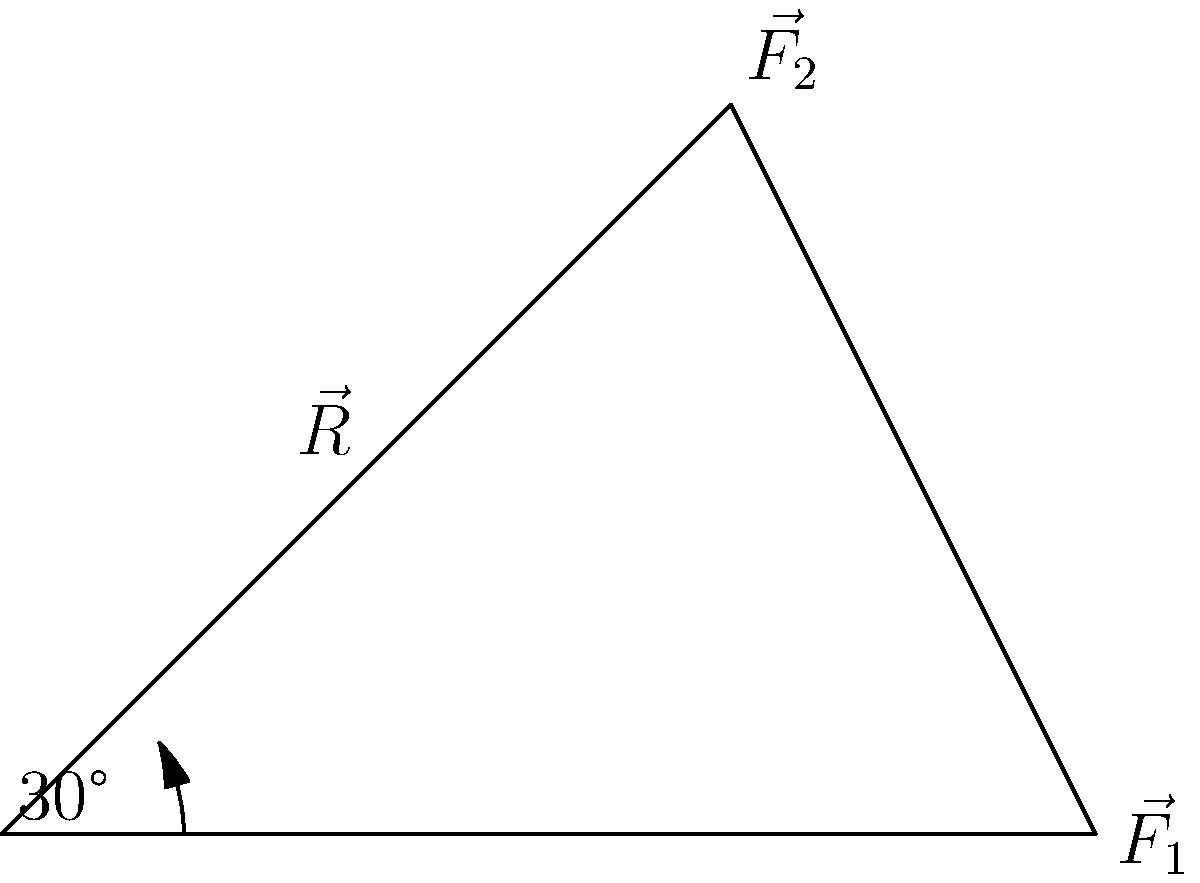A violinist is analyzing the forces acting on their bow during a performance. Two forces are applied to the bow: $\vec{F_1}$ with a magnitude of 3 N along the x-axis, and $\vec{F_2}$ with a magnitude of 2.83 N at an angle of 30° above the x-axis. Calculate the magnitude of the resultant force $\vec{R}$ acting on the bow. To find the magnitude of the resultant force, we'll use the following steps:

1) First, let's break down $\vec{F_2}$ into its x and y components:
   $F_{2x} = 2.83 \cos(30°) = 2.83 \cdot \frac{\sqrt{3}}{2} = 2.45$ N
   $F_{2y} = 2.83 \sin(30°) = 2.83 \cdot \frac{1}{2} = 1.415$ N

2) Now, we can sum the forces in the x and y directions:
   $R_x = F_1 + F_{2x} = 3 + 2.45 = 5.45$ N
   $R_y = F_{2y} = 1.415$ N

3) The magnitude of the resultant force can be calculated using the Pythagorean theorem:
   $|\vec{R}| = \sqrt{R_x^2 + R_y^2} = \sqrt{5.45^2 + 1.415^2}$

4) Simplifying:
   $|\vec{R}| = \sqrt{29.7025 + 2.002225} = \sqrt{31.704725}$

5) Calculating the final result:
   $|\vec{R}| \approx 5.63$ N

Therefore, the magnitude of the resultant force acting on the violin bow is approximately 5.63 N.
Answer: 5.63 N 